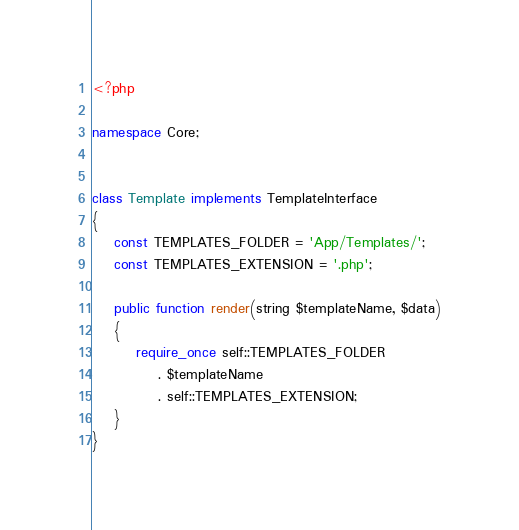<code> <loc_0><loc_0><loc_500><loc_500><_PHP_><?php

namespace Core;


class Template implements TemplateInterface
{
    const TEMPLATES_FOLDER = 'App/Templates/';
    const TEMPLATES_EXTENSION = '.php';

    public function render(string $templateName, $data)
    {
        require_once self::TEMPLATES_FOLDER
            . $templateName
            . self::TEMPLATES_EXTENSION;
    }
}</code> 